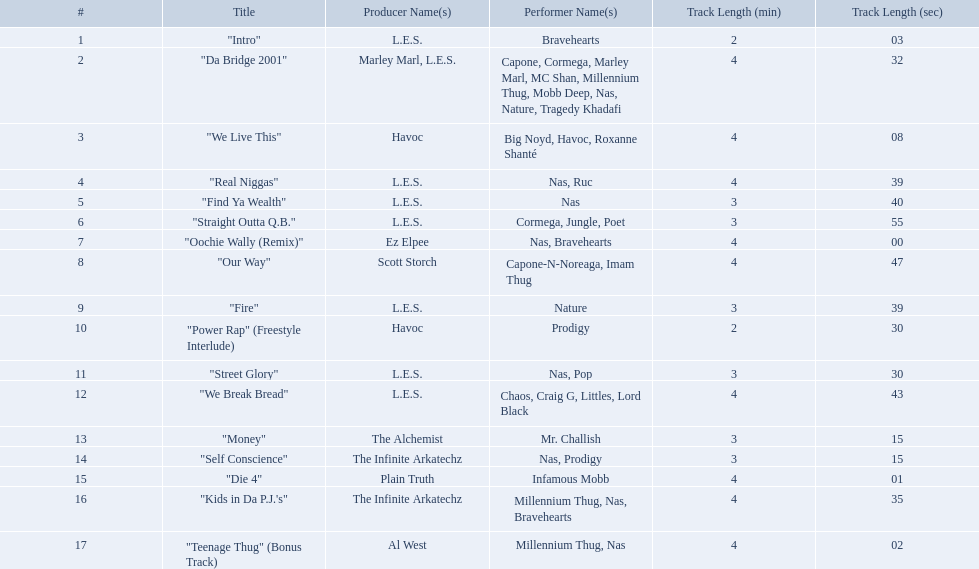How long is each song? 2:03, 4:32, 4:08, 4:39, 3:40, 3:55, 4:00, 4:47, 3:39, 2:30, 3:30, 4:43, 3:15, 3:15, 4:01, 4:35, 4:02. Of those, which length is the shortest? 2:03. What are all the songs on the album? "Intro", "Da Bridge 2001", "We Live This", "Real Niggas", "Find Ya Wealth", "Straight Outta Q.B.", "Oochie Wally (Remix)", "Our Way", "Fire", "Power Rap" (Freestyle Interlude), "Street Glory", "We Break Bread", "Money", "Self Conscience", "Die 4", "Kids in Da P.J.'s", "Teenage Thug" (Bonus Track). Which is the shortest? "Intro". How long is that song? 2:03. How long is each song? 2:03, 4:32, 4:08, 4:39, 3:40, 3:55, 4:00, 4:47, 3:39, 2:30, 3:30, 4:43, 3:15, 3:15, 4:01, 4:35, 4:02. What length is the longest? 4:47. 